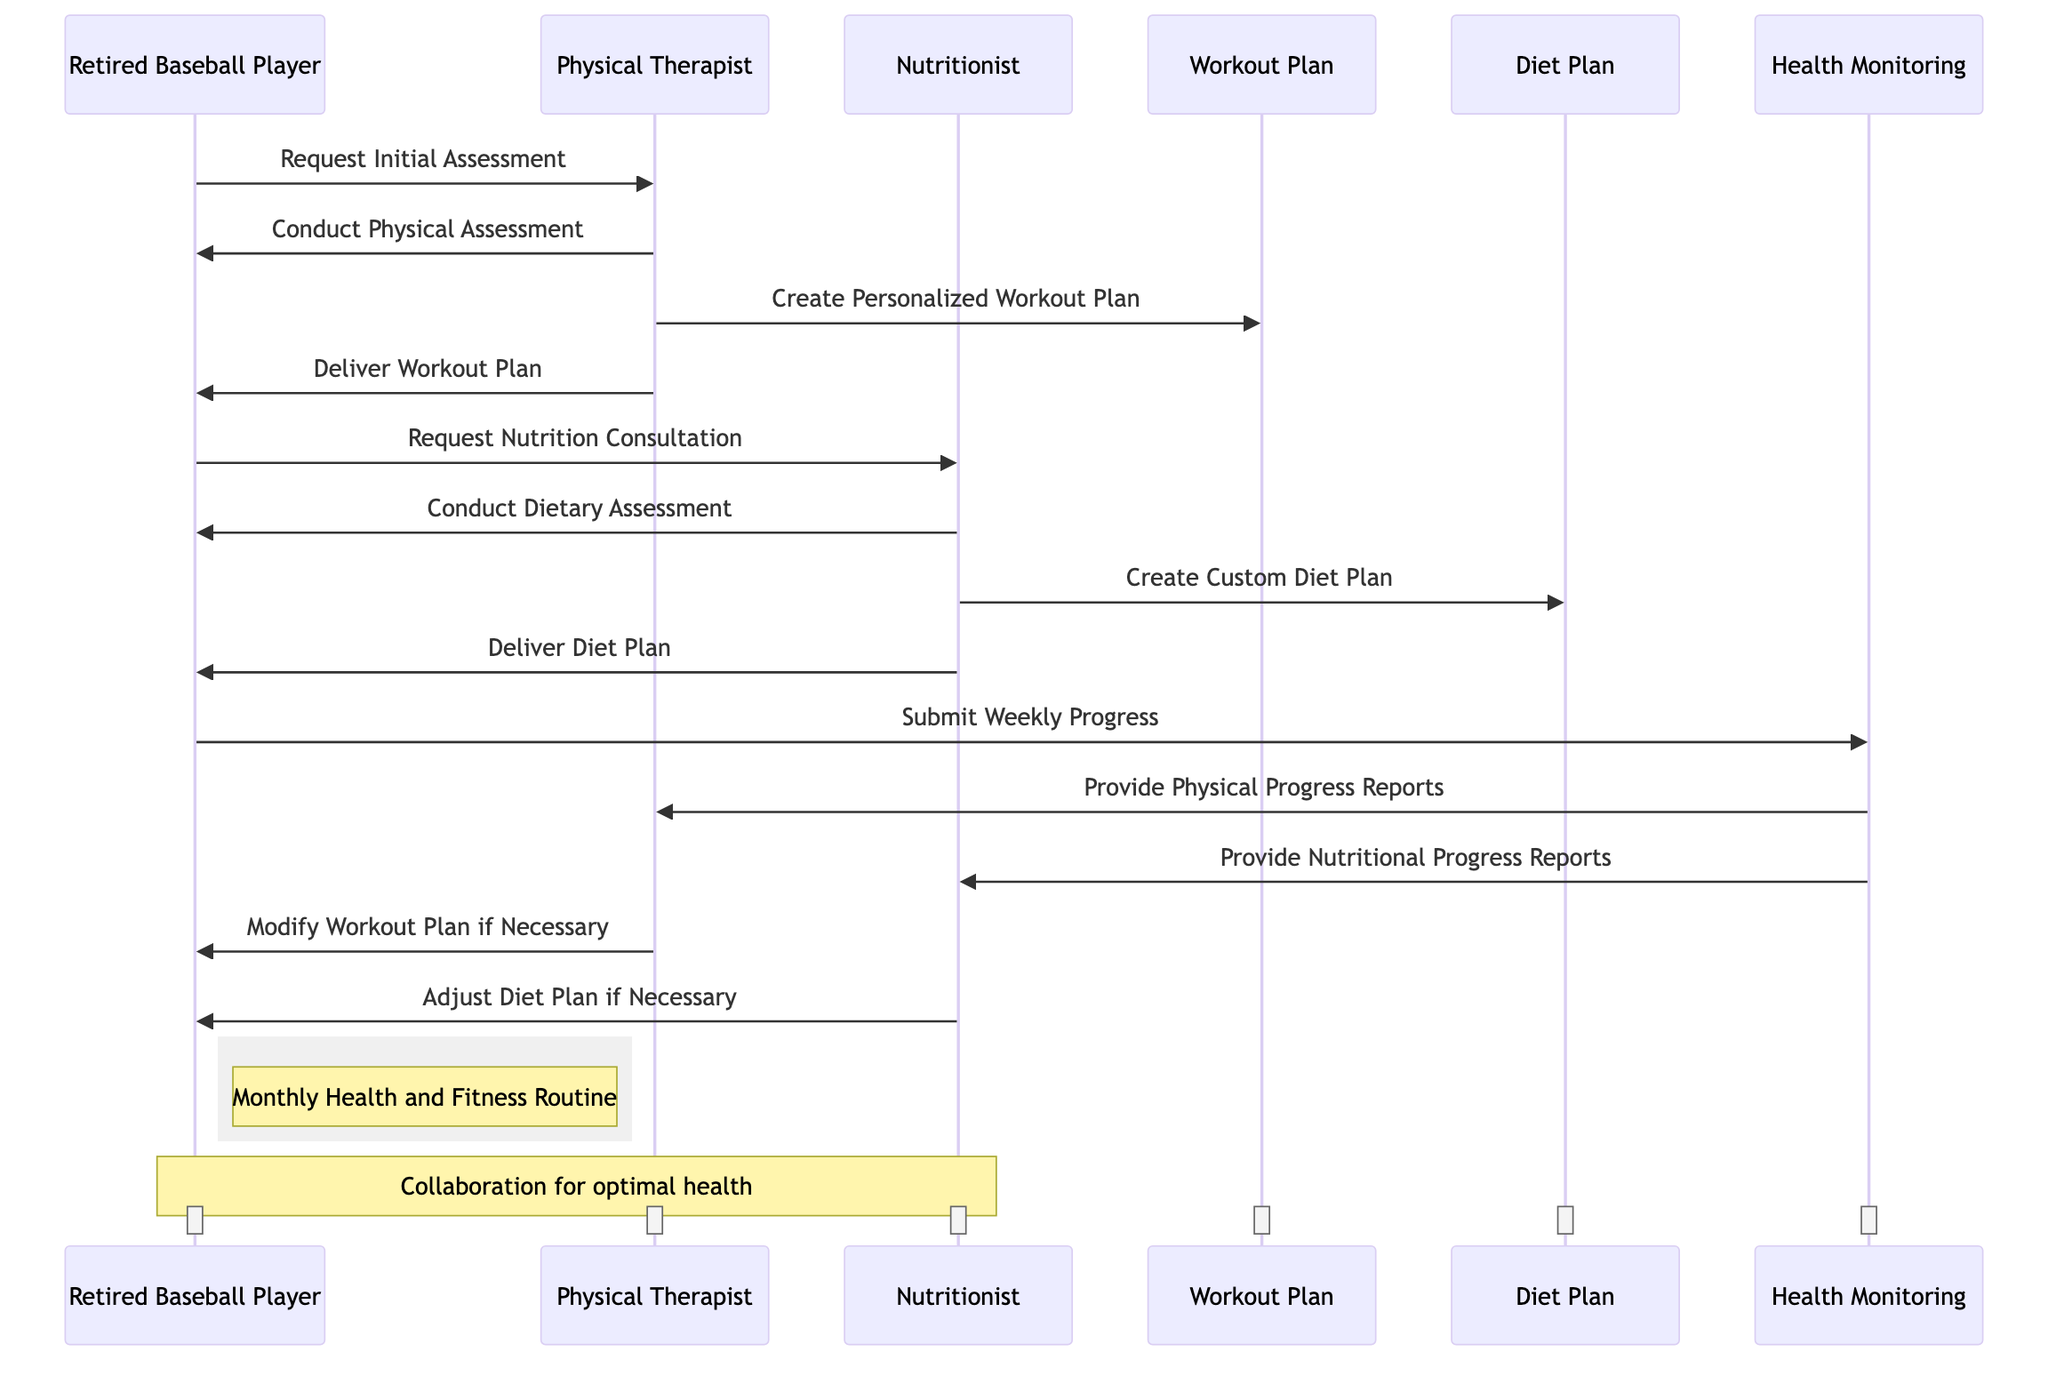What's the first request made by the Retired Baseball Player? The diagram shows that the Retired Baseball Player initiated the interaction by making a request to the Physical Therapist for the initial assessment. This is the first message from the Retired Baseball Player.
Answer: Request Initial Assessment How many plans are created in this routine? There are two specific plans illustrated in the diagram: the Workout Plan and the Diet Plan, which are created by the Physical Therapist and Nutritionist, respectively.
Answer: Two What does the Nutritionist do after conducting a dietary assessment? Following the dietary assessment conducted by the Nutritionist, the next action in the sequence is to create a custom diet plan for the Retired Baseball Player. This is a direct sequential flow indicated in the diagram.
Answer: Create Custom Diet Plan Which participant provides physical progress reports? In the diagram, the Health Monitoring object provides physical progress reports to the Physical Therapist as indicated in the messages exchanged. This indicates that the Physical Therapist is receiving updates on the Retired Baseball Player's physical condition.
Answer: Physical Therapist What action does the Physical Therapist take if necessary? If modifications are needed, the Physical Therapist is indicated to modify the workout plan based on the progress reports received from the health monitoring entity, thus ensuring the plan remains effective and aligned with the Retired Baseball Player’s progress.
Answer: Modify Workout Plan if Necessary Who does the Retired Baseball Player submit weekly progress to? According to the diagram, the Retired Baseball Player submits weekly progress to the Health Monitoring object, which is responsible for compiling and sharing this information with the Physical Therapist and Nutritionist.
Answer: Health Monitoring What happens after the Retired Baseball Player requests a nutrition consultation? After the Retired Baseball Player requests a nutrition consultation, the Nutritionist conducts a dietary assessment as the next step in the sequence, following the initial consultation request.
Answer: Conduct Dietary Assessment What is the purpose of the Health Monitoring object in this routine? The Health Monitoring object serves as the intermediary for tracking and reporting the Retired Baseball Player's progress related to both physical and nutritional aspects, facilitating communication between the Retired Baseball Player, Physical Therapist, and Nutritionist.
Answer: Provide Physical and Nutritional Progress Reports How many participants are involved in this health and fitness routine? The diagram includes three participants: Retired Baseball Player, Physical Therapist, and Nutritionist. These participants are involved in collaborative interactions throughout the routine as depicted in the diagram.
Answer: Three 